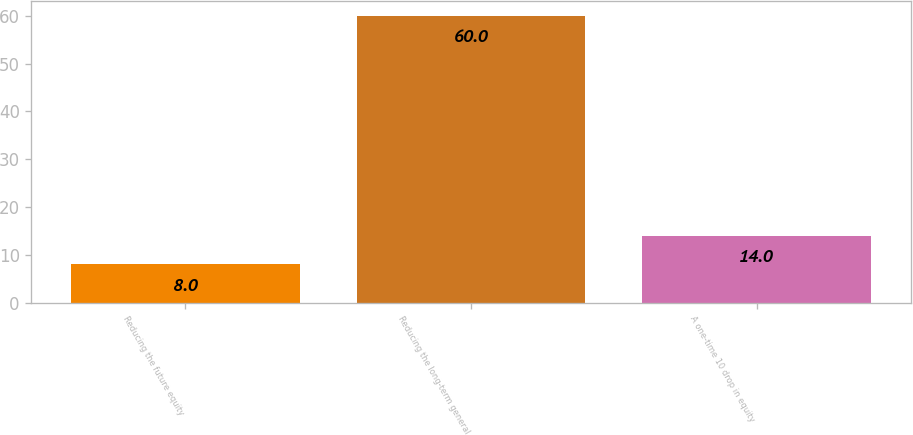Convert chart to OTSL. <chart><loc_0><loc_0><loc_500><loc_500><bar_chart><fcel>Reducing the future equity<fcel>Reducing the long-term general<fcel>A one-time 10 drop in equity<nl><fcel>8<fcel>60<fcel>14<nl></chart> 